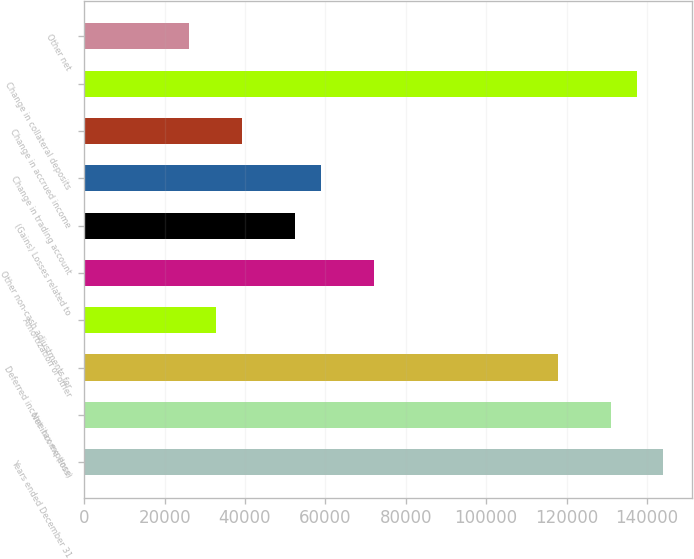Convert chart to OTSL. <chart><loc_0><loc_0><loc_500><loc_500><bar_chart><fcel>Years ended December 31<fcel>Net income (loss)<fcel>Deferred income tax expense<fcel>Amortization of other<fcel>Other non-cash adjustments for<fcel>(Gains) Losses related to<fcel>Change in trading account<fcel>Change in accrued income<fcel>Change in collateral deposits<fcel>Other net<nl><fcel>144055<fcel>130960<fcel>117865<fcel>32747.5<fcel>72032.5<fcel>52390<fcel>58937.5<fcel>39295<fcel>137508<fcel>26200<nl></chart> 